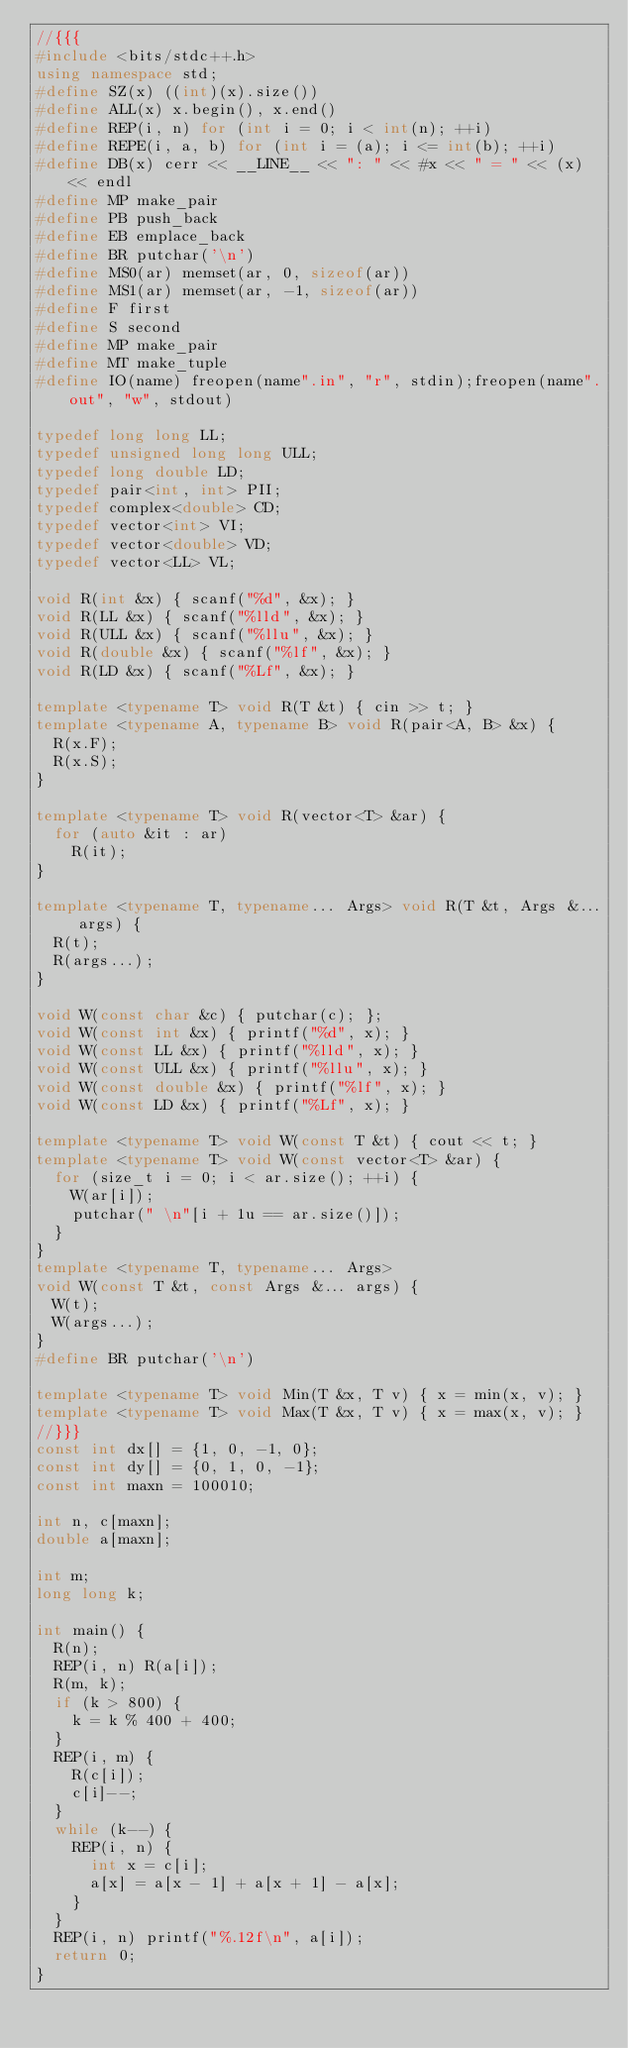Convert code to text. <code><loc_0><loc_0><loc_500><loc_500><_C++_>//{{{
#include <bits/stdc++.h>
using namespace std;
#define SZ(x) ((int)(x).size())
#define ALL(x) x.begin(), x.end()
#define REP(i, n) for (int i = 0; i < int(n); ++i)
#define REPE(i, a, b) for (int i = (a); i <= int(b); ++i)
#define DB(x) cerr << __LINE__ << ": " << #x << " = " << (x) << endl
#define MP make_pair
#define PB push_back
#define EB emplace_back
#define BR putchar('\n')
#define MS0(ar) memset(ar, 0, sizeof(ar))
#define MS1(ar) memset(ar, -1, sizeof(ar))
#define F first
#define S second
#define MP make_pair
#define MT make_tuple
#define IO(name) freopen(name".in", "r", stdin);freopen(name".out", "w", stdout)

typedef long long LL;
typedef unsigned long long ULL;
typedef long double LD;
typedef pair<int, int> PII;
typedef complex<double> CD;
typedef vector<int> VI;
typedef vector<double> VD;
typedef vector<LL> VL;

void R(int &x) { scanf("%d", &x); }
void R(LL &x) { scanf("%lld", &x); }
void R(ULL &x) { scanf("%llu", &x); }
void R(double &x) { scanf("%lf", &x); }
void R(LD &x) { scanf("%Lf", &x); }

template <typename T> void R(T &t) { cin >> t; }
template <typename A, typename B> void R(pair<A, B> &x) {
  R(x.F);
  R(x.S);
}

template <typename T> void R(vector<T> &ar) {
  for (auto &it : ar)
    R(it);
}

template <typename T, typename... Args> void R(T &t, Args &... args) {
  R(t);
  R(args...);
}

void W(const char &c) { putchar(c); };
void W(const int &x) { printf("%d", x); }
void W(const LL &x) { printf("%lld", x); }
void W(const ULL &x) { printf("%llu", x); }
void W(const double &x) { printf("%lf", x); }
void W(const LD &x) { printf("%Lf", x); }

template <typename T> void W(const T &t) { cout << t; }
template <typename T> void W(const vector<T> &ar) {
  for (size_t i = 0; i < ar.size(); ++i) {
    W(ar[i]);
    putchar(" \n"[i + 1u == ar.size()]);
  }
}
template <typename T, typename... Args>
void W(const T &t, const Args &... args) {
  W(t);
  W(args...);
}
#define BR putchar('\n')

template <typename T> void Min(T &x, T v) { x = min(x, v); }
template <typename T> void Max(T &x, T v) { x = max(x, v); }
//}}}
const int dx[] = {1, 0, -1, 0};
const int dy[] = {0, 1, 0, -1};
const int maxn = 100010;

int n, c[maxn];
double a[maxn];

int m;
long long k;

int main() {
  R(n);
  REP(i, n) R(a[i]);
  R(m, k);
  if (k > 800) {
    k = k % 400 + 400;
  }
  REP(i, m) {
    R(c[i]);
    c[i]--;
  }
  while (k--) {
    REP(i, n) {
      int x = c[i];
      a[x] = a[x - 1] + a[x + 1] - a[x];
    }
  }
  REP(i, n) printf("%.12f\n", a[i]);
  return 0;
}

</code> 